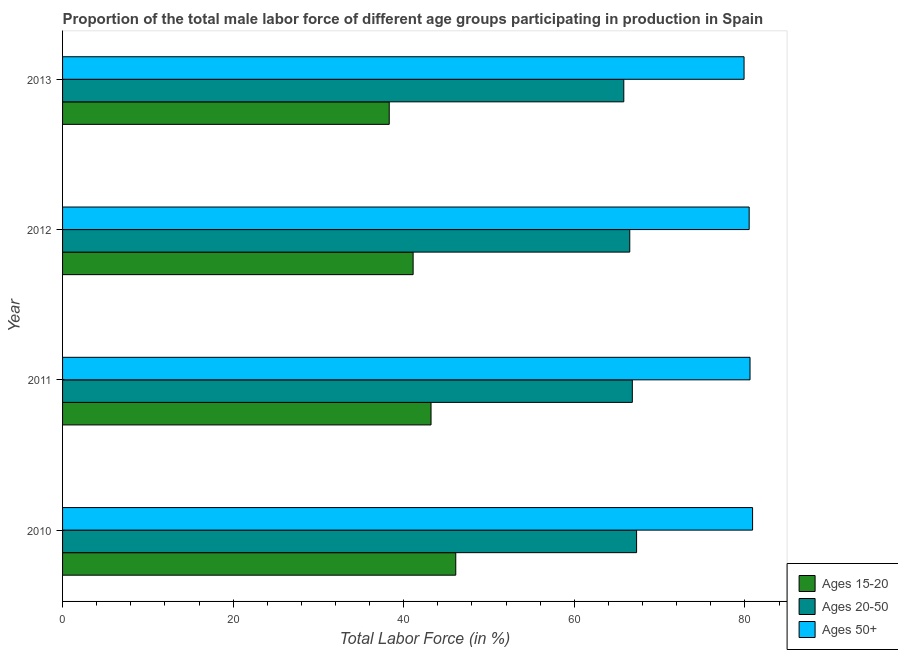How many different coloured bars are there?
Give a very brief answer. 3. How many groups of bars are there?
Ensure brevity in your answer.  4. In how many cases, is the number of bars for a given year not equal to the number of legend labels?
Offer a very short reply. 0. What is the percentage of male labor force above age 50 in 2012?
Give a very brief answer. 80.5. Across all years, what is the maximum percentage of male labor force above age 50?
Your response must be concise. 80.9. Across all years, what is the minimum percentage of male labor force within the age group 15-20?
Your response must be concise. 38.3. In which year was the percentage of male labor force within the age group 20-50 maximum?
Your response must be concise. 2010. In which year was the percentage of male labor force above age 50 minimum?
Keep it short and to the point. 2013. What is the total percentage of male labor force above age 50 in the graph?
Provide a succinct answer. 321.9. What is the difference between the percentage of male labor force within the age group 15-20 in 2012 and the percentage of male labor force within the age group 20-50 in 2013?
Offer a terse response. -24.7. What is the average percentage of male labor force within the age group 15-20 per year?
Your answer should be very brief. 42.17. In the year 2013, what is the difference between the percentage of male labor force above age 50 and percentage of male labor force within the age group 20-50?
Your answer should be compact. 14.1. In how many years, is the percentage of male labor force within the age group 20-50 greater than 76 %?
Give a very brief answer. 0. Is the percentage of male labor force above age 50 in 2010 less than that in 2011?
Your response must be concise. No. Is the difference between the percentage of male labor force within the age group 20-50 in 2012 and 2013 greater than the difference between the percentage of male labor force above age 50 in 2012 and 2013?
Make the answer very short. Yes. What is the difference between the highest and the second highest percentage of male labor force above age 50?
Ensure brevity in your answer.  0.3. In how many years, is the percentage of male labor force above age 50 greater than the average percentage of male labor force above age 50 taken over all years?
Your answer should be compact. 3. What does the 2nd bar from the top in 2012 represents?
Your answer should be compact. Ages 20-50. What does the 3rd bar from the bottom in 2012 represents?
Ensure brevity in your answer.  Ages 50+. Is it the case that in every year, the sum of the percentage of male labor force within the age group 15-20 and percentage of male labor force within the age group 20-50 is greater than the percentage of male labor force above age 50?
Provide a succinct answer. Yes. Are the values on the major ticks of X-axis written in scientific E-notation?
Your answer should be compact. No. Does the graph contain any zero values?
Provide a short and direct response. No. Does the graph contain grids?
Keep it short and to the point. No. Where does the legend appear in the graph?
Keep it short and to the point. Bottom right. What is the title of the graph?
Make the answer very short. Proportion of the total male labor force of different age groups participating in production in Spain. What is the label or title of the X-axis?
Keep it short and to the point. Total Labor Force (in %). What is the Total Labor Force (in %) in Ages 15-20 in 2010?
Your response must be concise. 46.1. What is the Total Labor Force (in %) in Ages 20-50 in 2010?
Offer a very short reply. 67.3. What is the Total Labor Force (in %) in Ages 50+ in 2010?
Give a very brief answer. 80.9. What is the Total Labor Force (in %) in Ages 15-20 in 2011?
Offer a very short reply. 43.2. What is the Total Labor Force (in %) of Ages 20-50 in 2011?
Make the answer very short. 66.8. What is the Total Labor Force (in %) of Ages 50+ in 2011?
Offer a very short reply. 80.6. What is the Total Labor Force (in %) of Ages 15-20 in 2012?
Provide a short and direct response. 41.1. What is the Total Labor Force (in %) in Ages 20-50 in 2012?
Offer a very short reply. 66.5. What is the Total Labor Force (in %) in Ages 50+ in 2012?
Your response must be concise. 80.5. What is the Total Labor Force (in %) of Ages 15-20 in 2013?
Keep it short and to the point. 38.3. What is the Total Labor Force (in %) in Ages 20-50 in 2013?
Make the answer very short. 65.8. What is the Total Labor Force (in %) of Ages 50+ in 2013?
Your response must be concise. 79.9. Across all years, what is the maximum Total Labor Force (in %) in Ages 15-20?
Give a very brief answer. 46.1. Across all years, what is the maximum Total Labor Force (in %) of Ages 20-50?
Your answer should be very brief. 67.3. Across all years, what is the maximum Total Labor Force (in %) in Ages 50+?
Your answer should be compact. 80.9. Across all years, what is the minimum Total Labor Force (in %) of Ages 15-20?
Keep it short and to the point. 38.3. Across all years, what is the minimum Total Labor Force (in %) of Ages 20-50?
Provide a short and direct response. 65.8. Across all years, what is the minimum Total Labor Force (in %) of Ages 50+?
Your answer should be compact. 79.9. What is the total Total Labor Force (in %) of Ages 15-20 in the graph?
Offer a very short reply. 168.7. What is the total Total Labor Force (in %) in Ages 20-50 in the graph?
Your answer should be compact. 266.4. What is the total Total Labor Force (in %) of Ages 50+ in the graph?
Ensure brevity in your answer.  321.9. What is the difference between the Total Labor Force (in %) of Ages 15-20 in 2010 and that in 2011?
Offer a terse response. 2.9. What is the difference between the Total Labor Force (in %) of Ages 20-50 in 2010 and that in 2012?
Give a very brief answer. 0.8. What is the difference between the Total Labor Force (in %) in Ages 15-20 in 2010 and that in 2013?
Your response must be concise. 7.8. What is the difference between the Total Labor Force (in %) in Ages 20-50 in 2010 and that in 2013?
Your answer should be very brief. 1.5. What is the difference between the Total Labor Force (in %) in Ages 50+ in 2010 and that in 2013?
Your answer should be compact. 1. What is the difference between the Total Labor Force (in %) in Ages 20-50 in 2011 and that in 2012?
Offer a very short reply. 0.3. What is the difference between the Total Labor Force (in %) of Ages 15-20 in 2011 and that in 2013?
Offer a very short reply. 4.9. What is the difference between the Total Labor Force (in %) of Ages 50+ in 2011 and that in 2013?
Your response must be concise. 0.7. What is the difference between the Total Labor Force (in %) in Ages 15-20 in 2012 and that in 2013?
Your response must be concise. 2.8. What is the difference between the Total Labor Force (in %) of Ages 15-20 in 2010 and the Total Labor Force (in %) of Ages 20-50 in 2011?
Your response must be concise. -20.7. What is the difference between the Total Labor Force (in %) in Ages 15-20 in 2010 and the Total Labor Force (in %) in Ages 50+ in 2011?
Your answer should be very brief. -34.5. What is the difference between the Total Labor Force (in %) in Ages 15-20 in 2010 and the Total Labor Force (in %) in Ages 20-50 in 2012?
Provide a succinct answer. -20.4. What is the difference between the Total Labor Force (in %) of Ages 15-20 in 2010 and the Total Labor Force (in %) of Ages 50+ in 2012?
Your answer should be very brief. -34.4. What is the difference between the Total Labor Force (in %) in Ages 20-50 in 2010 and the Total Labor Force (in %) in Ages 50+ in 2012?
Your response must be concise. -13.2. What is the difference between the Total Labor Force (in %) in Ages 15-20 in 2010 and the Total Labor Force (in %) in Ages 20-50 in 2013?
Offer a very short reply. -19.7. What is the difference between the Total Labor Force (in %) of Ages 15-20 in 2010 and the Total Labor Force (in %) of Ages 50+ in 2013?
Provide a succinct answer. -33.8. What is the difference between the Total Labor Force (in %) of Ages 20-50 in 2010 and the Total Labor Force (in %) of Ages 50+ in 2013?
Give a very brief answer. -12.6. What is the difference between the Total Labor Force (in %) in Ages 15-20 in 2011 and the Total Labor Force (in %) in Ages 20-50 in 2012?
Make the answer very short. -23.3. What is the difference between the Total Labor Force (in %) of Ages 15-20 in 2011 and the Total Labor Force (in %) of Ages 50+ in 2012?
Provide a succinct answer. -37.3. What is the difference between the Total Labor Force (in %) of Ages 20-50 in 2011 and the Total Labor Force (in %) of Ages 50+ in 2012?
Ensure brevity in your answer.  -13.7. What is the difference between the Total Labor Force (in %) of Ages 15-20 in 2011 and the Total Labor Force (in %) of Ages 20-50 in 2013?
Keep it short and to the point. -22.6. What is the difference between the Total Labor Force (in %) of Ages 15-20 in 2011 and the Total Labor Force (in %) of Ages 50+ in 2013?
Offer a very short reply. -36.7. What is the difference between the Total Labor Force (in %) in Ages 20-50 in 2011 and the Total Labor Force (in %) in Ages 50+ in 2013?
Provide a short and direct response. -13.1. What is the difference between the Total Labor Force (in %) of Ages 15-20 in 2012 and the Total Labor Force (in %) of Ages 20-50 in 2013?
Give a very brief answer. -24.7. What is the difference between the Total Labor Force (in %) of Ages 15-20 in 2012 and the Total Labor Force (in %) of Ages 50+ in 2013?
Offer a terse response. -38.8. What is the average Total Labor Force (in %) of Ages 15-20 per year?
Your response must be concise. 42.17. What is the average Total Labor Force (in %) in Ages 20-50 per year?
Offer a terse response. 66.6. What is the average Total Labor Force (in %) of Ages 50+ per year?
Your answer should be compact. 80.47. In the year 2010, what is the difference between the Total Labor Force (in %) in Ages 15-20 and Total Labor Force (in %) in Ages 20-50?
Keep it short and to the point. -21.2. In the year 2010, what is the difference between the Total Labor Force (in %) in Ages 15-20 and Total Labor Force (in %) in Ages 50+?
Offer a very short reply. -34.8. In the year 2011, what is the difference between the Total Labor Force (in %) of Ages 15-20 and Total Labor Force (in %) of Ages 20-50?
Offer a very short reply. -23.6. In the year 2011, what is the difference between the Total Labor Force (in %) of Ages 15-20 and Total Labor Force (in %) of Ages 50+?
Keep it short and to the point. -37.4. In the year 2011, what is the difference between the Total Labor Force (in %) in Ages 20-50 and Total Labor Force (in %) in Ages 50+?
Keep it short and to the point. -13.8. In the year 2012, what is the difference between the Total Labor Force (in %) in Ages 15-20 and Total Labor Force (in %) in Ages 20-50?
Give a very brief answer. -25.4. In the year 2012, what is the difference between the Total Labor Force (in %) of Ages 15-20 and Total Labor Force (in %) of Ages 50+?
Provide a short and direct response. -39.4. In the year 2012, what is the difference between the Total Labor Force (in %) of Ages 20-50 and Total Labor Force (in %) of Ages 50+?
Provide a succinct answer. -14. In the year 2013, what is the difference between the Total Labor Force (in %) in Ages 15-20 and Total Labor Force (in %) in Ages 20-50?
Your answer should be compact. -27.5. In the year 2013, what is the difference between the Total Labor Force (in %) in Ages 15-20 and Total Labor Force (in %) in Ages 50+?
Provide a succinct answer. -41.6. In the year 2013, what is the difference between the Total Labor Force (in %) in Ages 20-50 and Total Labor Force (in %) in Ages 50+?
Your response must be concise. -14.1. What is the ratio of the Total Labor Force (in %) of Ages 15-20 in 2010 to that in 2011?
Give a very brief answer. 1.07. What is the ratio of the Total Labor Force (in %) of Ages 20-50 in 2010 to that in 2011?
Keep it short and to the point. 1.01. What is the ratio of the Total Labor Force (in %) in Ages 50+ in 2010 to that in 2011?
Ensure brevity in your answer.  1. What is the ratio of the Total Labor Force (in %) in Ages 15-20 in 2010 to that in 2012?
Ensure brevity in your answer.  1.12. What is the ratio of the Total Labor Force (in %) of Ages 20-50 in 2010 to that in 2012?
Offer a very short reply. 1.01. What is the ratio of the Total Labor Force (in %) of Ages 15-20 in 2010 to that in 2013?
Give a very brief answer. 1.2. What is the ratio of the Total Labor Force (in %) in Ages 20-50 in 2010 to that in 2013?
Provide a succinct answer. 1.02. What is the ratio of the Total Labor Force (in %) in Ages 50+ in 2010 to that in 2013?
Ensure brevity in your answer.  1.01. What is the ratio of the Total Labor Force (in %) in Ages 15-20 in 2011 to that in 2012?
Offer a terse response. 1.05. What is the ratio of the Total Labor Force (in %) of Ages 20-50 in 2011 to that in 2012?
Make the answer very short. 1. What is the ratio of the Total Labor Force (in %) of Ages 15-20 in 2011 to that in 2013?
Keep it short and to the point. 1.13. What is the ratio of the Total Labor Force (in %) in Ages 20-50 in 2011 to that in 2013?
Offer a very short reply. 1.02. What is the ratio of the Total Labor Force (in %) of Ages 50+ in 2011 to that in 2013?
Offer a terse response. 1.01. What is the ratio of the Total Labor Force (in %) in Ages 15-20 in 2012 to that in 2013?
Make the answer very short. 1.07. What is the ratio of the Total Labor Force (in %) in Ages 20-50 in 2012 to that in 2013?
Provide a succinct answer. 1.01. What is the ratio of the Total Labor Force (in %) of Ages 50+ in 2012 to that in 2013?
Offer a terse response. 1.01. What is the difference between the highest and the second highest Total Labor Force (in %) of Ages 50+?
Provide a short and direct response. 0.3. What is the difference between the highest and the lowest Total Labor Force (in %) of Ages 20-50?
Make the answer very short. 1.5. 